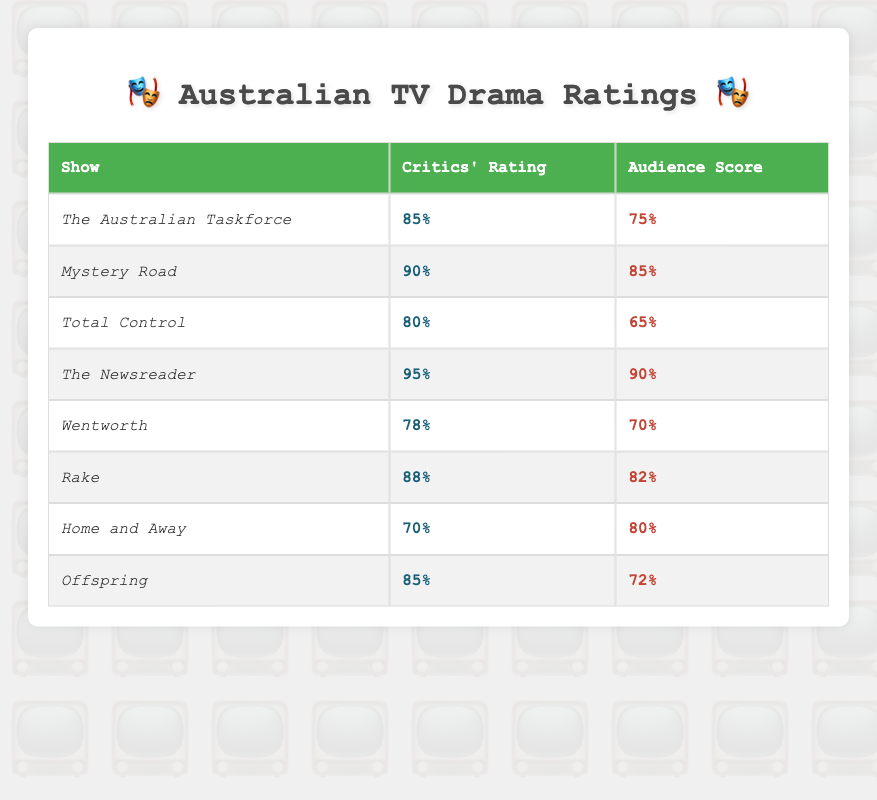What is the critics' rating for "The Newsreader"? The table lists "The Newsreader" under the "Show" column, and its "Critics' Rating" is shown as 95%.
Answer: 95% Which show has the highest audience score? By comparing the audience scores of all shows listed, "The Newsreader" has the highest score at 90%.
Answer: The Newsreader What is the average critics' rating of all the shows? To find the average critics' rating, sum all the critics' ratings: (85 + 90 + 80 + 95 + 78 + 88 + 70 + 85) =  691. There are 8 shows, so the average is 691/8 = 86.375.
Answer: 86.375 Do critics generally rate shows higher than audience scores? Comparing each show's critics' ratings with their audience scores shows that in 5 out of the 8 shows, critics rated higher (The Australian Taskforce, Total Control, Wentworth, Offspring, and Home and Away). Therefore, it's true that critics generally rate shows higher than audience scores.
Answer: Yes Which show has the largest difference between critics' ratings and audience scores? Calculate the differences for each show: "The Australian Taskforce" (85-75=10), "Mystery Road" (90-85=5), "Total Control" (80-65=15), "The Newsreader" (95-90=5), "Wentworth" (78-70=8), "Rake" (88-82=6), "Home and Away" (70-80=10), "Offspring" (85-72=13). The largest difference is 15 for "Total Control".
Answer: Total Control How many shows have audience scores equal to or above 80%? By examining the audience scores, the shows with scores of 80% or more are "Mystery Road" (85%), "The Newsreader" (90%), "Rake" (82%), and "Home and Away" (80%). Therefore, there are 4 shows.
Answer: 4 